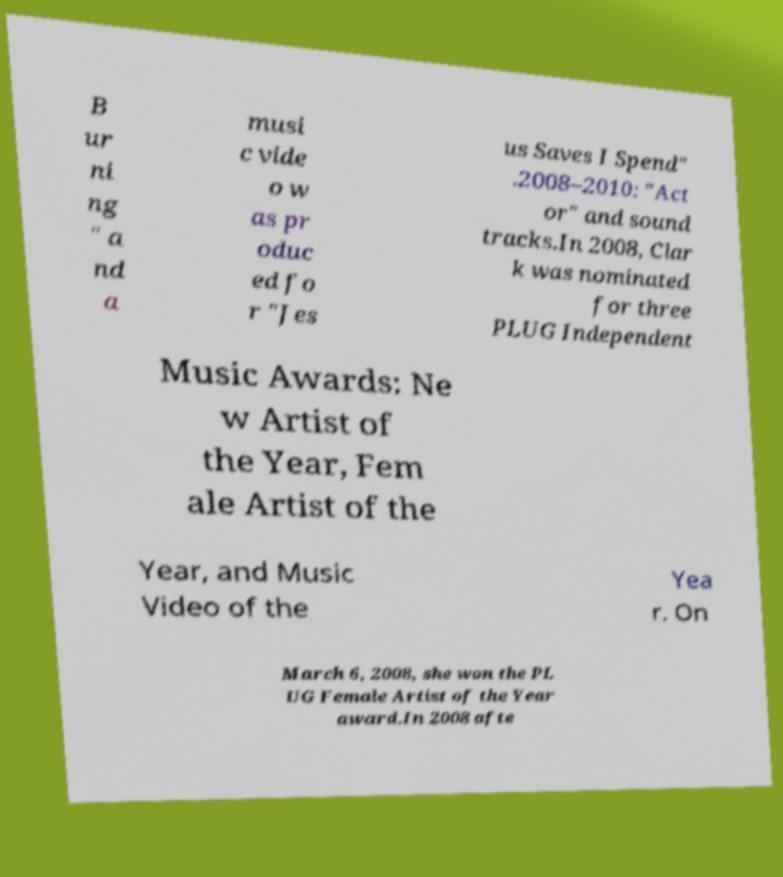For documentation purposes, I need the text within this image transcribed. Could you provide that? B ur ni ng " a nd a musi c vide o w as pr oduc ed fo r "Jes us Saves I Spend" .2008–2010: "Act or" and sound tracks.In 2008, Clar k was nominated for three PLUG Independent Music Awards: Ne w Artist of the Year, Fem ale Artist of the Year, and Music Video of the Yea r. On March 6, 2008, she won the PL UG Female Artist of the Year award.In 2008 afte 